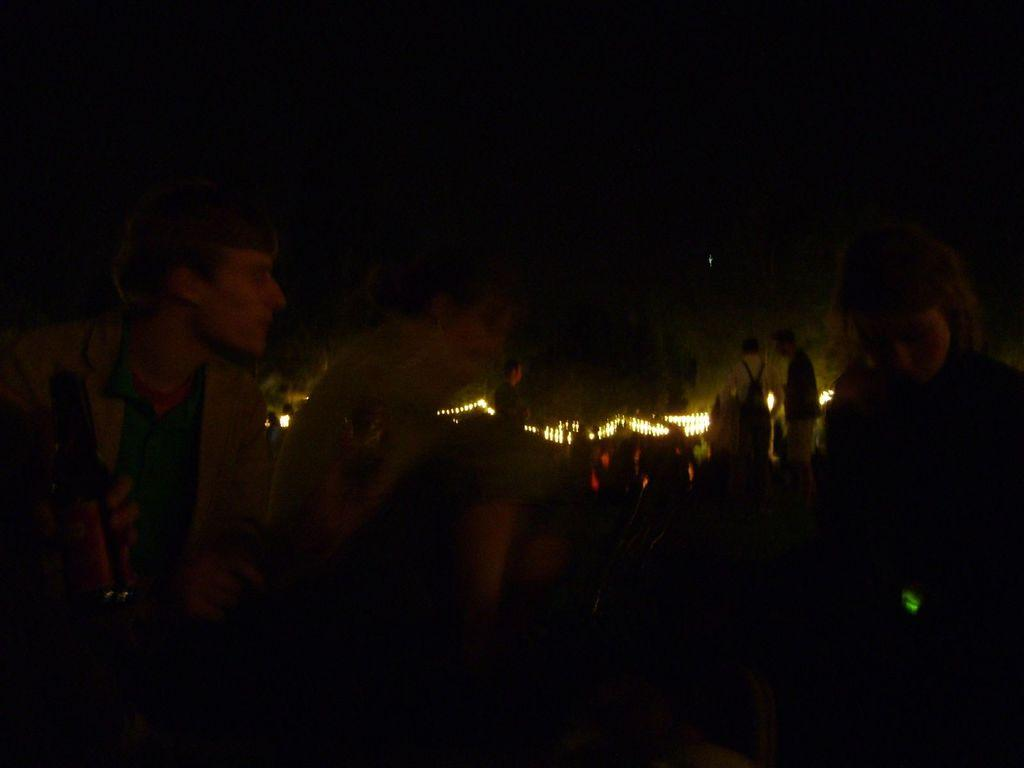What is happening in the image? There are people standing in the image. How would you describe the overall appearance of the image? The image has a dark appearance. What can be seen in the background of the image? There are lights visible in the background of the image. Reasoning: Let' Let's think step by step in order to produce the conversation. We start by identifying the main subject in the image, which is the people standing. Then, we describe the overall appearance of the image, noting that it has a dark appearance. Finally, we focus on the background of the image, mentioning the presence of lights. Each question is designed to elicit a specific detail about the image that is known from the provided facts. Absurd Question/Answer: What type of rock is being used as a chair by the dolls in the image? There are no dolls or rocks present in the image; it features people standing in a dark environment with lights visible in the background. 